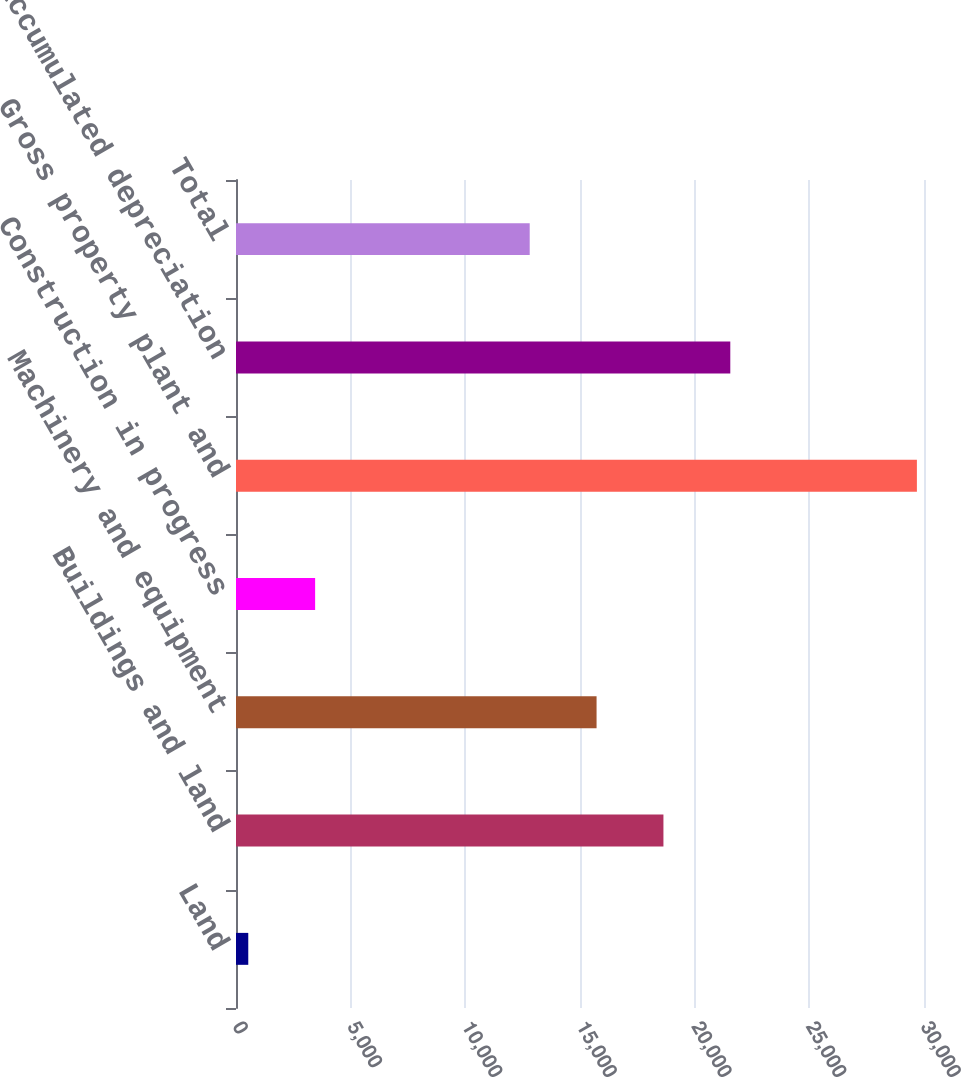Convert chart. <chart><loc_0><loc_0><loc_500><loc_500><bar_chart><fcel>Land<fcel>Buildings and land<fcel>Machinery and equipment<fcel>Construction in progress<fcel>Gross property plant and<fcel>Less accumulated depreciation<fcel>Total<nl><fcel>535<fcel>18638<fcel>15722.5<fcel>3450.5<fcel>29690<fcel>21553.5<fcel>12807<nl></chart> 